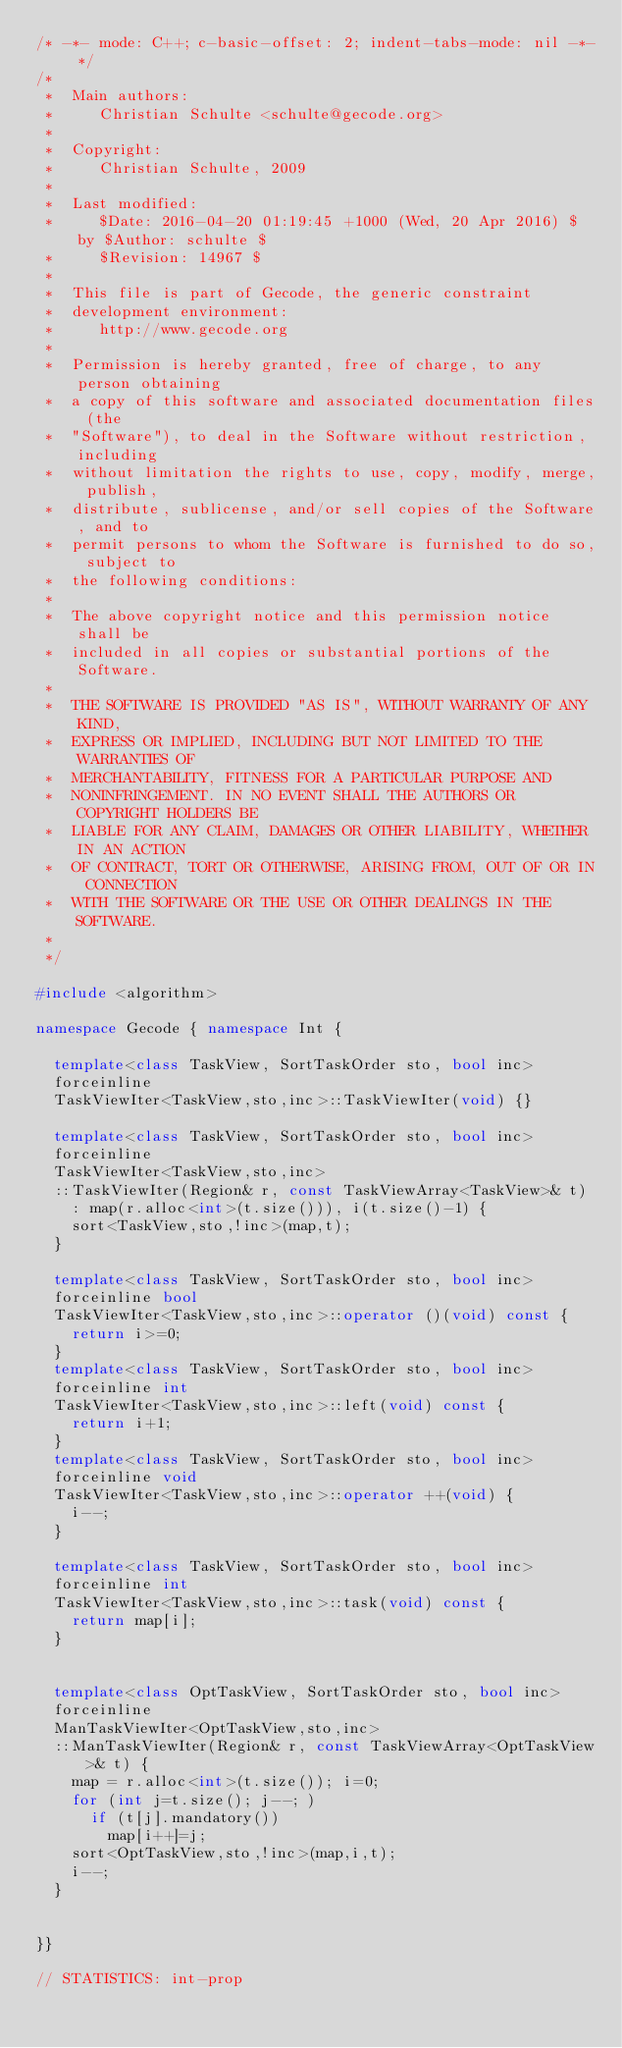<code> <loc_0><loc_0><loc_500><loc_500><_C++_>/* -*- mode: C++; c-basic-offset: 2; indent-tabs-mode: nil -*- */
/*
 *  Main authors:
 *     Christian Schulte <schulte@gecode.org>
 *
 *  Copyright:
 *     Christian Schulte, 2009
 *
 *  Last modified:
 *     $Date: 2016-04-20 01:19:45 +1000 (Wed, 20 Apr 2016) $ by $Author: schulte $
 *     $Revision: 14967 $
 *
 *  This file is part of Gecode, the generic constraint
 *  development environment:
 *     http://www.gecode.org
 *
 *  Permission is hereby granted, free of charge, to any person obtaining
 *  a copy of this software and associated documentation files (the
 *  "Software"), to deal in the Software without restriction, including
 *  without limitation the rights to use, copy, modify, merge, publish,
 *  distribute, sublicense, and/or sell copies of the Software, and to
 *  permit persons to whom the Software is furnished to do so, subject to
 *  the following conditions:
 *
 *  The above copyright notice and this permission notice shall be
 *  included in all copies or substantial portions of the Software.
 *
 *  THE SOFTWARE IS PROVIDED "AS IS", WITHOUT WARRANTY OF ANY KIND,
 *  EXPRESS OR IMPLIED, INCLUDING BUT NOT LIMITED TO THE WARRANTIES OF
 *  MERCHANTABILITY, FITNESS FOR A PARTICULAR PURPOSE AND
 *  NONINFRINGEMENT. IN NO EVENT SHALL THE AUTHORS OR COPYRIGHT HOLDERS BE
 *  LIABLE FOR ANY CLAIM, DAMAGES OR OTHER LIABILITY, WHETHER IN AN ACTION
 *  OF CONTRACT, TORT OR OTHERWISE, ARISING FROM, OUT OF OR IN CONNECTION
 *  WITH THE SOFTWARE OR THE USE OR OTHER DEALINGS IN THE SOFTWARE.
 *
 */

#include <algorithm>

namespace Gecode { namespace Int {

  template<class TaskView, SortTaskOrder sto, bool inc>
  forceinline
  TaskViewIter<TaskView,sto,inc>::TaskViewIter(void) {}

  template<class TaskView, SortTaskOrder sto, bool inc>
  forceinline
  TaskViewIter<TaskView,sto,inc>
  ::TaskViewIter(Region& r, const TaskViewArray<TaskView>& t)
    : map(r.alloc<int>(t.size())), i(t.size()-1) {
    sort<TaskView,sto,!inc>(map,t);
  }

  template<class TaskView, SortTaskOrder sto, bool inc>
  forceinline bool
  TaskViewIter<TaskView,sto,inc>::operator ()(void) const {
    return i>=0;
  }
  template<class TaskView, SortTaskOrder sto, bool inc>
  forceinline int
  TaskViewIter<TaskView,sto,inc>::left(void) const {
    return i+1;
  }
  template<class TaskView, SortTaskOrder sto, bool inc>
  forceinline void
  TaskViewIter<TaskView,sto,inc>::operator ++(void) {
    i--;
  }

  template<class TaskView, SortTaskOrder sto, bool inc>
  forceinline int
  TaskViewIter<TaskView,sto,inc>::task(void) const {
    return map[i];
  }


  template<class OptTaskView, SortTaskOrder sto, bool inc>
  forceinline
  ManTaskViewIter<OptTaskView,sto,inc>
  ::ManTaskViewIter(Region& r, const TaskViewArray<OptTaskView>& t) {
    map = r.alloc<int>(t.size()); i=0;
    for (int j=t.size(); j--; )
      if (t[j].mandatory())
        map[i++]=j;
    sort<OptTaskView,sto,!inc>(map,i,t);
    i--;
  }


}}

// STATISTICS: int-prop
</code> 